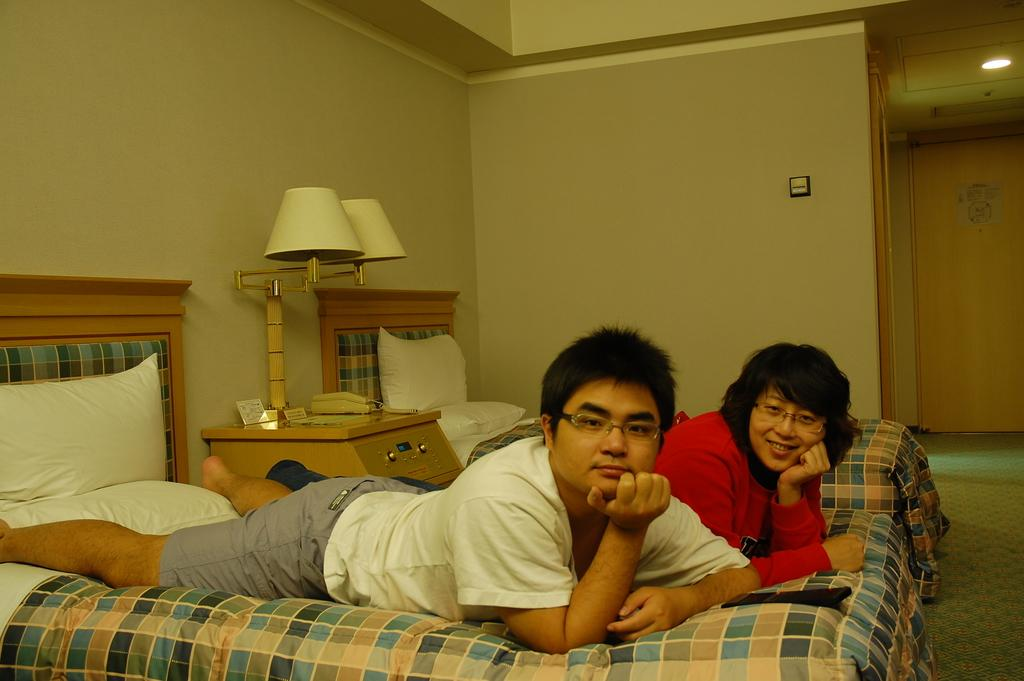What is the main setting of the image? There is a room in the image. What are the people in the room doing? A woman and a man are lying on a bed in the room. What furniture is present in the room? There is a table in the room. What objects can be seen on the table? There is a phone and a lamp on the table. What type of plantation can be seen through the window in the image? There is no window or plantation visible in the image. What color is the neck of the woman in the image? There is no neck visible in the image, as the woman is lying on a bed with her head on a pillow. 